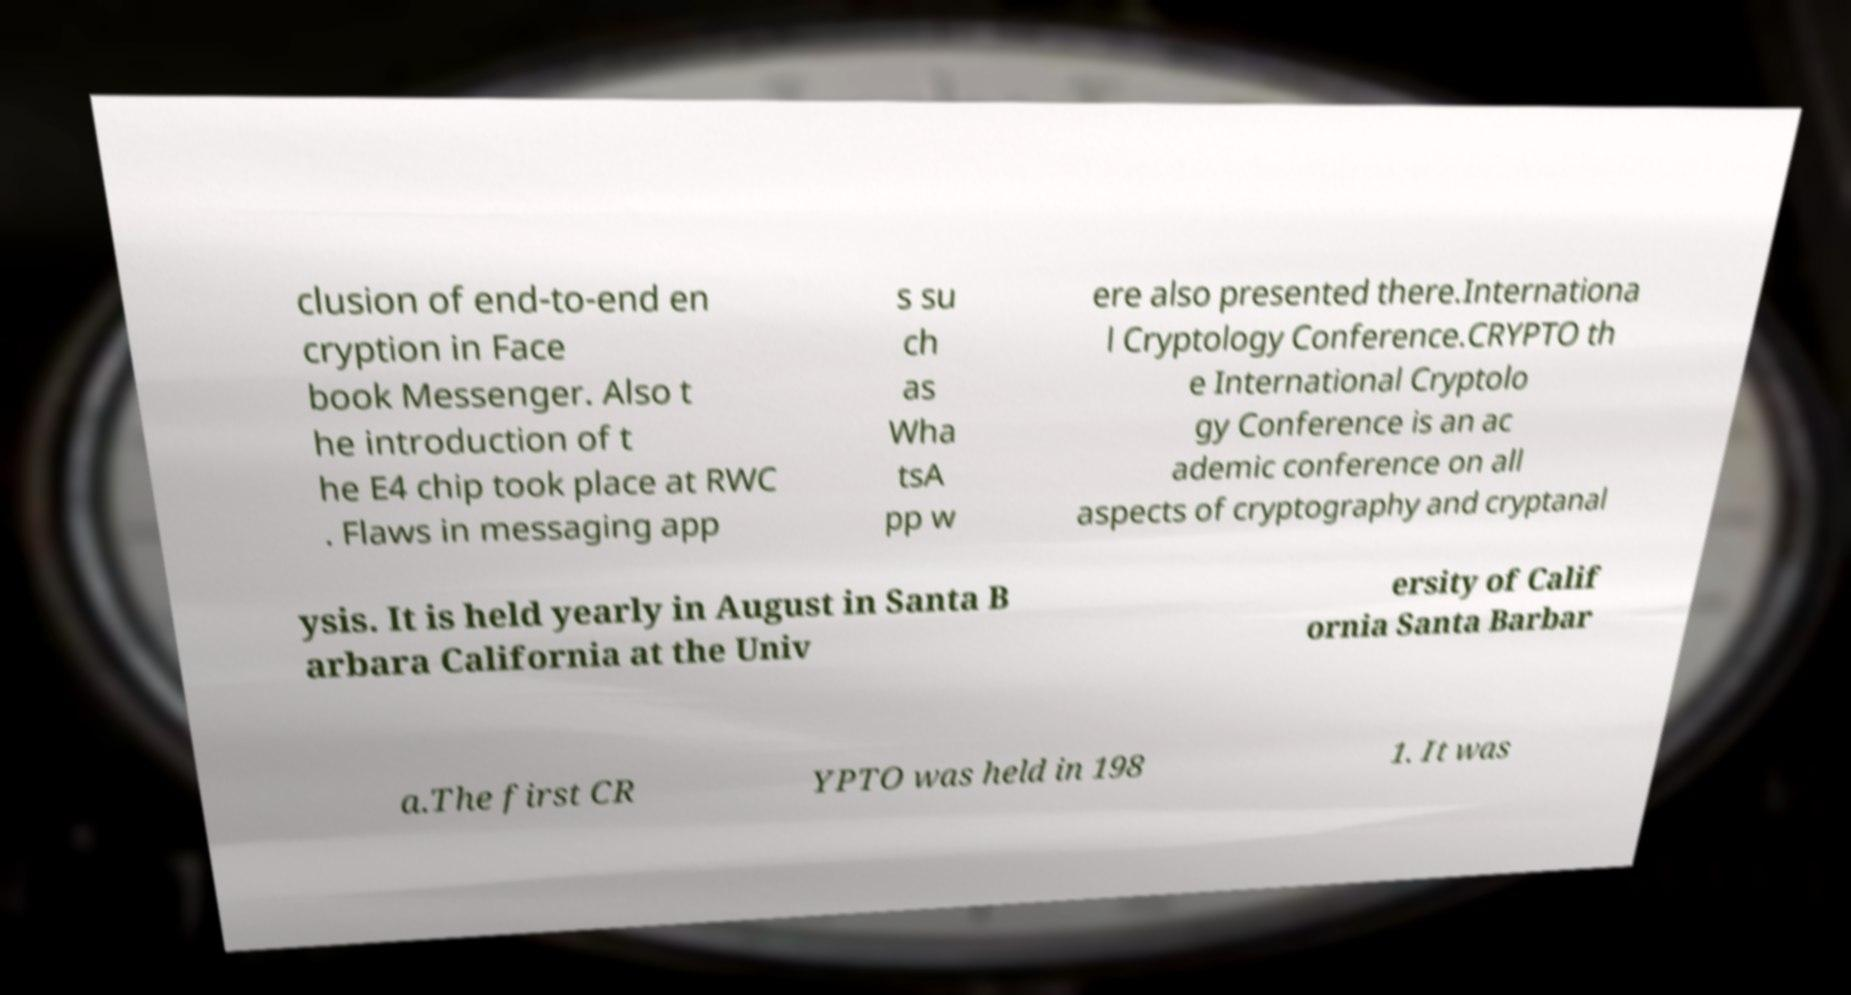Please read and relay the text visible in this image. What does it say? clusion of end-to-end en cryption in Face book Messenger. Also t he introduction of t he E4 chip took place at RWC . Flaws in messaging app s su ch as Wha tsA pp w ere also presented there.Internationa l Cryptology Conference.CRYPTO th e International Cryptolo gy Conference is an ac ademic conference on all aspects of cryptography and cryptanal ysis. It is held yearly in August in Santa B arbara California at the Univ ersity of Calif ornia Santa Barbar a.The first CR YPTO was held in 198 1. It was 